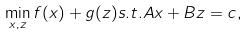<formula> <loc_0><loc_0><loc_500><loc_500>\min _ { x , z } f ( x ) + g ( z ) s . t . A x + B z = c ,</formula> 